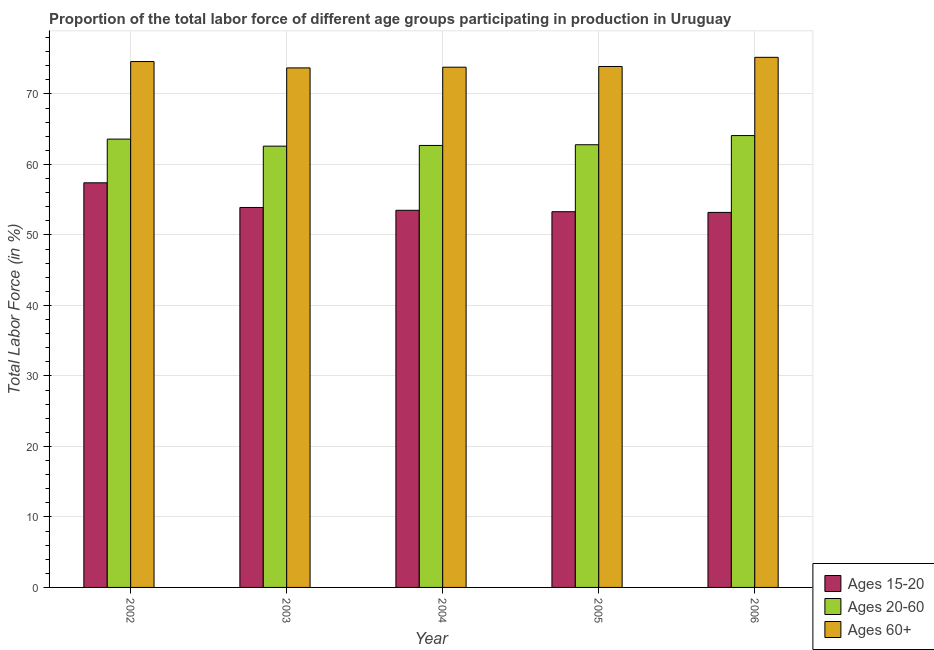How many different coloured bars are there?
Give a very brief answer. 3. How many groups of bars are there?
Provide a short and direct response. 5. Are the number of bars per tick equal to the number of legend labels?
Your response must be concise. Yes. Are the number of bars on each tick of the X-axis equal?
Keep it short and to the point. Yes. How many bars are there on the 1st tick from the right?
Your response must be concise. 3. What is the percentage of labor force within the age group 15-20 in 2004?
Provide a short and direct response. 53.5. Across all years, what is the maximum percentage of labor force above age 60?
Offer a very short reply. 75.2. Across all years, what is the minimum percentage of labor force above age 60?
Ensure brevity in your answer.  73.7. In which year was the percentage of labor force within the age group 15-20 maximum?
Provide a short and direct response. 2002. In which year was the percentage of labor force above age 60 minimum?
Provide a short and direct response. 2003. What is the total percentage of labor force within the age group 20-60 in the graph?
Offer a terse response. 315.8. What is the difference between the percentage of labor force within the age group 20-60 in 2003 and that in 2004?
Keep it short and to the point. -0.1. What is the difference between the percentage of labor force above age 60 in 2006 and the percentage of labor force within the age group 20-60 in 2004?
Provide a short and direct response. 1.4. What is the average percentage of labor force within the age group 20-60 per year?
Make the answer very short. 63.16. What is the ratio of the percentage of labor force within the age group 15-20 in 2002 to that in 2004?
Provide a short and direct response. 1.07. Is the percentage of labor force within the age group 15-20 in 2002 less than that in 2006?
Ensure brevity in your answer.  No. What is the difference between the highest and the second highest percentage of labor force within the age group 20-60?
Your response must be concise. 0.5. What is the difference between the highest and the lowest percentage of labor force above age 60?
Ensure brevity in your answer.  1.5. Is the sum of the percentage of labor force within the age group 20-60 in 2002 and 2004 greater than the maximum percentage of labor force within the age group 15-20 across all years?
Keep it short and to the point. Yes. What does the 1st bar from the left in 2006 represents?
Provide a succinct answer. Ages 15-20. What does the 1st bar from the right in 2004 represents?
Offer a very short reply. Ages 60+. Are all the bars in the graph horizontal?
Keep it short and to the point. No. How many years are there in the graph?
Give a very brief answer. 5. What is the difference between two consecutive major ticks on the Y-axis?
Your answer should be very brief. 10. Are the values on the major ticks of Y-axis written in scientific E-notation?
Give a very brief answer. No. Where does the legend appear in the graph?
Your answer should be compact. Bottom right. What is the title of the graph?
Offer a terse response. Proportion of the total labor force of different age groups participating in production in Uruguay. Does "Machinery" appear as one of the legend labels in the graph?
Provide a succinct answer. No. What is the label or title of the X-axis?
Provide a succinct answer. Year. What is the Total Labor Force (in %) of Ages 15-20 in 2002?
Your answer should be compact. 57.4. What is the Total Labor Force (in %) of Ages 20-60 in 2002?
Your response must be concise. 63.6. What is the Total Labor Force (in %) in Ages 60+ in 2002?
Offer a very short reply. 74.6. What is the Total Labor Force (in %) of Ages 15-20 in 2003?
Offer a terse response. 53.9. What is the Total Labor Force (in %) in Ages 20-60 in 2003?
Give a very brief answer. 62.6. What is the Total Labor Force (in %) of Ages 60+ in 2003?
Ensure brevity in your answer.  73.7. What is the Total Labor Force (in %) in Ages 15-20 in 2004?
Make the answer very short. 53.5. What is the Total Labor Force (in %) in Ages 20-60 in 2004?
Keep it short and to the point. 62.7. What is the Total Labor Force (in %) in Ages 60+ in 2004?
Your answer should be very brief. 73.8. What is the Total Labor Force (in %) of Ages 15-20 in 2005?
Provide a succinct answer. 53.3. What is the Total Labor Force (in %) of Ages 20-60 in 2005?
Make the answer very short. 62.8. What is the Total Labor Force (in %) in Ages 60+ in 2005?
Your answer should be compact. 73.9. What is the Total Labor Force (in %) in Ages 15-20 in 2006?
Offer a terse response. 53.2. What is the Total Labor Force (in %) of Ages 20-60 in 2006?
Provide a short and direct response. 64.1. What is the Total Labor Force (in %) of Ages 60+ in 2006?
Your answer should be very brief. 75.2. Across all years, what is the maximum Total Labor Force (in %) of Ages 15-20?
Your answer should be very brief. 57.4. Across all years, what is the maximum Total Labor Force (in %) in Ages 20-60?
Keep it short and to the point. 64.1. Across all years, what is the maximum Total Labor Force (in %) of Ages 60+?
Keep it short and to the point. 75.2. Across all years, what is the minimum Total Labor Force (in %) of Ages 15-20?
Your response must be concise. 53.2. Across all years, what is the minimum Total Labor Force (in %) in Ages 20-60?
Your answer should be very brief. 62.6. Across all years, what is the minimum Total Labor Force (in %) of Ages 60+?
Keep it short and to the point. 73.7. What is the total Total Labor Force (in %) in Ages 15-20 in the graph?
Offer a terse response. 271.3. What is the total Total Labor Force (in %) in Ages 20-60 in the graph?
Provide a short and direct response. 315.8. What is the total Total Labor Force (in %) of Ages 60+ in the graph?
Make the answer very short. 371.2. What is the difference between the Total Labor Force (in %) in Ages 15-20 in 2002 and that in 2003?
Ensure brevity in your answer.  3.5. What is the difference between the Total Labor Force (in %) in Ages 60+ in 2002 and that in 2003?
Keep it short and to the point. 0.9. What is the difference between the Total Labor Force (in %) of Ages 15-20 in 2002 and that in 2004?
Your response must be concise. 3.9. What is the difference between the Total Labor Force (in %) in Ages 60+ in 2002 and that in 2004?
Offer a very short reply. 0.8. What is the difference between the Total Labor Force (in %) of Ages 15-20 in 2002 and that in 2005?
Your answer should be very brief. 4.1. What is the difference between the Total Labor Force (in %) in Ages 60+ in 2002 and that in 2005?
Give a very brief answer. 0.7. What is the difference between the Total Labor Force (in %) of Ages 20-60 in 2002 and that in 2006?
Provide a succinct answer. -0.5. What is the difference between the Total Labor Force (in %) of Ages 60+ in 2002 and that in 2006?
Make the answer very short. -0.6. What is the difference between the Total Labor Force (in %) of Ages 15-20 in 2003 and that in 2004?
Give a very brief answer. 0.4. What is the difference between the Total Labor Force (in %) of Ages 60+ in 2003 and that in 2004?
Provide a succinct answer. -0.1. What is the difference between the Total Labor Force (in %) in Ages 20-60 in 2003 and that in 2005?
Offer a terse response. -0.2. What is the difference between the Total Labor Force (in %) of Ages 20-60 in 2003 and that in 2006?
Provide a succinct answer. -1.5. What is the difference between the Total Labor Force (in %) of Ages 60+ in 2003 and that in 2006?
Keep it short and to the point. -1.5. What is the difference between the Total Labor Force (in %) in Ages 15-20 in 2004 and that in 2005?
Keep it short and to the point. 0.2. What is the difference between the Total Labor Force (in %) of Ages 60+ in 2004 and that in 2005?
Your response must be concise. -0.1. What is the difference between the Total Labor Force (in %) of Ages 15-20 in 2004 and that in 2006?
Give a very brief answer. 0.3. What is the difference between the Total Labor Force (in %) of Ages 20-60 in 2004 and that in 2006?
Your answer should be very brief. -1.4. What is the difference between the Total Labor Force (in %) of Ages 60+ in 2004 and that in 2006?
Ensure brevity in your answer.  -1.4. What is the difference between the Total Labor Force (in %) in Ages 20-60 in 2005 and that in 2006?
Provide a succinct answer. -1.3. What is the difference between the Total Labor Force (in %) in Ages 60+ in 2005 and that in 2006?
Keep it short and to the point. -1.3. What is the difference between the Total Labor Force (in %) of Ages 15-20 in 2002 and the Total Labor Force (in %) of Ages 20-60 in 2003?
Your answer should be very brief. -5.2. What is the difference between the Total Labor Force (in %) in Ages 15-20 in 2002 and the Total Labor Force (in %) in Ages 60+ in 2003?
Keep it short and to the point. -16.3. What is the difference between the Total Labor Force (in %) of Ages 20-60 in 2002 and the Total Labor Force (in %) of Ages 60+ in 2003?
Keep it short and to the point. -10.1. What is the difference between the Total Labor Force (in %) of Ages 15-20 in 2002 and the Total Labor Force (in %) of Ages 60+ in 2004?
Provide a short and direct response. -16.4. What is the difference between the Total Labor Force (in %) in Ages 15-20 in 2002 and the Total Labor Force (in %) in Ages 20-60 in 2005?
Provide a short and direct response. -5.4. What is the difference between the Total Labor Force (in %) in Ages 15-20 in 2002 and the Total Labor Force (in %) in Ages 60+ in 2005?
Keep it short and to the point. -16.5. What is the difference between the Total Labor Force (in %) of Ages 15-20 in 2002 and the Total Labor Force (in %) of Ages 20-60 in 2006?
Provide a short and direct response. -6.7. What is the difference between the Total Labor Force (in %) in Ages 15-20 in 2002 and the Total Labor Force (in %) in Ages 60+ in 2006?
Ensure brevity in your answer.  -17.8. What is the difference between the Total Labor Force (in %) of Ages 15-20 in 2003 and the Total Labor Force (in %) of Ages 60+ in 2004?
Ensure brevity in your answer.  -19.9. What is the difference between the Total Labor Force (in %) of Ages 15-20 in 2003 and the Total Labor Force (in %) of Ages 20-60 in 2005?
Your answer should be compact. -8.9. What is the difference between the Total Labor Force (in %) of Ages 20-60 in 2003 and the Total Labor Force (in %) of Ages 60+ in 2005?
Your answer should be compact. -11.3. What is the difference between the Total Labor Force (in %) in Ages 15-20 in 2003 and the Total Labor Force (in %) in Ages 60+ in 2006?
Give a very brief answer. -21.3. What is the difference between the Total Labor Force (in %) of Ages 20-60 in 2003 and the Total Labor Force (in %) of Ages 60+ in 2006?
Your response must be concise. -12.6. What is the difference between the Total Labor Force (in %) in Ages 15-20 in 2004 and the Total Labor Force (in %) in Ages 20-60 in 2005?
Keep it short and to the point. -9.3. What is the difference between the Total Labor Force (in %) in Ages 15-20 in 2004 and the Total Labor Force (in %) in Ages 60+ in 2005?
Offer a very short reply. -20.4. What is the difference between the Total Labor Force (in %) of Ages 20-60 in 2004 and the Total Labor Force (in %) of Ages 60+ in 2005?
Your response must be concise. -11.2. What is the difference between the Total Labor Force (in %) in Ages 15-20 in 2004 and the Total Labor Force (in %) in Ages 20-60 in 2006?
Keep it short and to the point. -10.6. What is the difference between the Total Labor Force (in %) in Ages 15-20 in 2004 and the Total Labor Force (in %) in Ages 60+ in 2006?
Provide a succinct answer. -21.7. What is the difference between the Total Labor Force (in %) in Ages 15-20 in 2005 and the Total Labor Force (in %) in Ages 60+ in 2006?
Your answer should be compact. -21.9. What is the difference between the Total Labor Force (in %) in Ages 20-60 in 2005 and the Total Labor Force (in %) in Ages 60+ in 2006?
Offer a terse response. -12.4. What is the average Total Labor Force (in %) in Ages 15-20 per year?
Give a very brief answer. 54.26. What is the average Total Labor Force (in %) of Ages 20-60 per year?
Your answer should be compact. 63.16. What is the average Total Labor Force (in %) of Ages 60+ per year?
Your answer should be very brief. 74.24. In the year 2002, what is the difference between the Total Labor Force (in %) of Ages 15-20 and Total Labor Force (in %) of Ages 20-60?
Provide a succinct answer. -6.2. In the year 2002, what is the difference between the Total Labor Force (in %) of Ages 15-20 and Total Labor Force (in %) of Ages 60+?
Keep it short and to the point. -17.2. In the year 2003, what is the difference between the Total Labor Force (in %) of Ages 15-20 and Total Labor Force (in %) of Ages 60+?
Keep it short and to the point. -19.8. In the year 2003, what is the difference between the Total Labor Force (in %) in Ages 20-60 and Total Labor Force (in %) in Ages 60+?
Make the answer very short. -11.1. In the year 2004, what is the difference between the Total Labor Force (in %) of Ages 15-20 and Total Labor Force (in %) of Ages 20-60?
Provide a succinct answer. -9.2. In the year 2004, what is the difference between the Total Labor Force (in %) in Ages 15-20 and Total Labor Force (in %) in Ages 60+?
Ensure brevity in your answer.  -20.3. In the year 2005, what is the difference between the Total Labor Force (in %) of Ages 15-20 and Total Labor Force (in %) of Ages 60+?
Provide a succinct answer. -20.6. In the year 2006, what is the difference between the Total Labor Force (in %) in Ages 15-20 and Total Labor Force (in %) in Ages 60+?
Give a very brief answer. -22. In the year 2006, what is the difference between the Total Labor Force (in %) of Ages 20-60 and Total Labor Force (in %) of Ages 60+?
Your answer should be compact. -11.1. What is the ratio of the Total Labor Force (in %) of Ages 15-20 in 2002 to that in 2003?
Your answer should be very brief. 1.06. What is the ratio of the Total Labor Force (in %) in Ages 60+ in 2002 to that in 2003?
Provide a succinct answer. 1.01. What is the ratio of the Total Labor Force (in %) of Ages 15-20 in 2002 to that in 2004?
Make the answer very short. 1.07. What is the ratio of the Total Labor Force (in %) of Ages 20-60 in 2002 to that in 2004?
Your answer should be compact. 1.01. What is the ratio of the Total Labor Force (in %) in Ages 60+ in 2002 to that in 2004?
Provide a short and direct response. 1.01. What is the ratio of the Total Labor Force (in %) in Ages 15-20 in 2002 to that in 2005?
Your answer should be very brief. 1.08. What is the ratio of the Total Labor Force (in %) in Ages 20-60 in 2002 to that in 2005?
Offer a terse response. 1.01. What is the ratio of the Total Labor Force (in %) of Ages 60+ in 2002 to that in 2005?
Provide a short and direct response. 1.01. What is the ratio of the Total Labor Force (in %) of Ages 15-20 in 2002 to that in 2006?
Keep it short and to the point. 1.08. What is the ratio of the Total Labor Force (in %) in Ages 60+ in 2002 to that in 2006?
Ensure brevity in your answer.  0.99. What is the ratio of the Total Labor Force (in %) of Ages 15-20 in 2003 to that in 2004?
Provide a succinct answer. 1.01. What is the ratio of the Total Labor Force (in %) of Ages 20-60 in 2003 to that in 2004?
Your response must be concise. 1. What is the ratio of the Total Labor Force (in %) of Ages 15-20 in 2003 to that in 2005?
Give a very brief answer. 1.01. What is the ratio of the Total Labor Force (in %) in Ages 20-60 in 2003 to that in 2005?
Your answer should be compact. 1. What is the ratio of the Total Labor Force (in %) in Ages 60+ in 2003 to that in 2005?
Provide a succinct answer. 1. What is the ratio of the Total Labor Force (in %) of Ages 15-20 in 2003 to that in 2006?
Your answer should be very brief. 1.01. What is the ratio of the Total Labor Force (in %) in Ages 20-60 in 2003 to that in 2006?
Keep it short and to the point. 0.98. What is the ratio of the Total Labor Force (in %) in Ages 60+ in 2003 to that in 2006?
Offer a terse response. 0.98. What is the ratio of the Total Labor Force (in %) in Ages 20-60 in 2004 to that in 2005?
Give a very brief answer. 1. What is the ratio of the Total Labor Force (in %) in Ages 15-20 in 2004 to that in 2006?
Your response must be concise. 1.01. What is the ratio of the Total Labor Force (in %) of Ages 20-60 in 2004 to that in 2006?
Your answer should be compact. 0.98. What is the ratio of the Total Labor Force (in %) of Ages 60+ in 2004 to that in 2006?
Ensure brevity in your answer.  0.98. What is the ratio of the Total Labor Force (in %) of Ages 20-60 in 2005 to that in 2006?
Make the answer very short. 0.98. What is the ratio of the Total Labor Force (in %) in Ages 60+ in 2005 to that in 2006?
Your answer should be very brief. 0.98. What is the difference between the highest and the second highest Total Labor Force (in %) of Ages 20-60?
Make the answer very short. 0.5. What is the difference between the highest and the lowest Total Labor Force (in %) of Ages 15-20?
Ensure brevity in your answer.  4.2. What is the difference between the highest and the lowest Total Labor Force (in %) of Ages 20-60?
Your answer should be very brief. 1.5. 